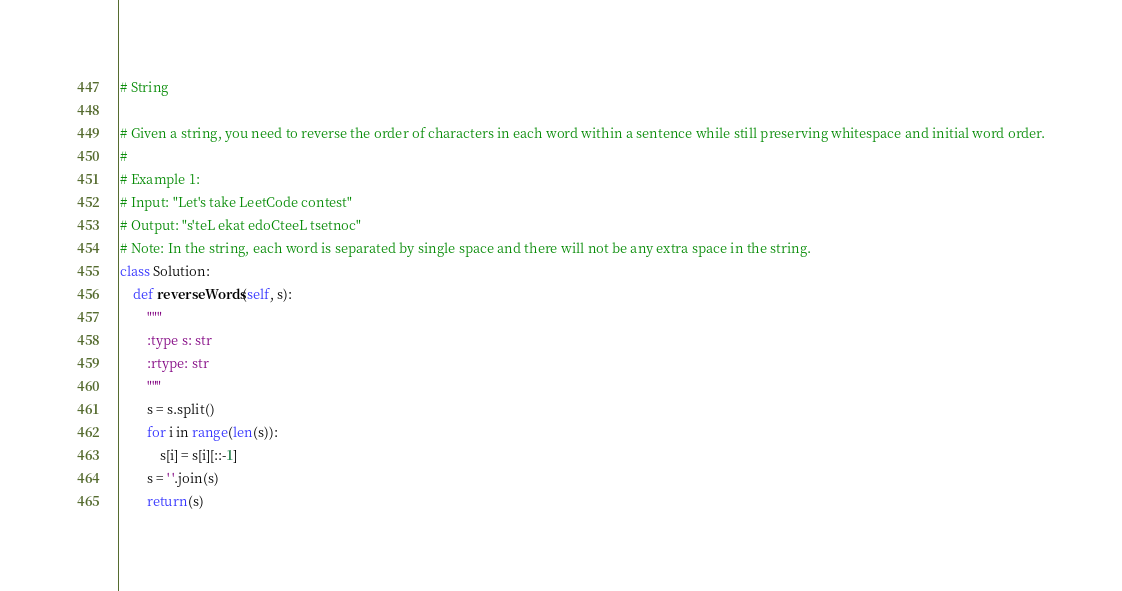<code> <loc_0><loc_0><loc_500><loc_500><_Python_># String

# Given a string, you need to reverse the order of characters in each word within a sentence while still preserving whitespace and initial word order.
#
# Example 1:
# Input: "Let's take LeetCode contest"
# Output: "s'teL ekat edoCteeL tsetnoc"
# Note: In the string, each word is separated by single space and there will not be any extra space in the string.
class Solution:
    def reverseWords(self, s):
        """
        :type s: str
        :rtype: str
        """
        s = s.split()
        for i in range(len(s)):
            s[i] = s[i][::-1]
        s = ' '.join(s)
        return(s)
</code> 